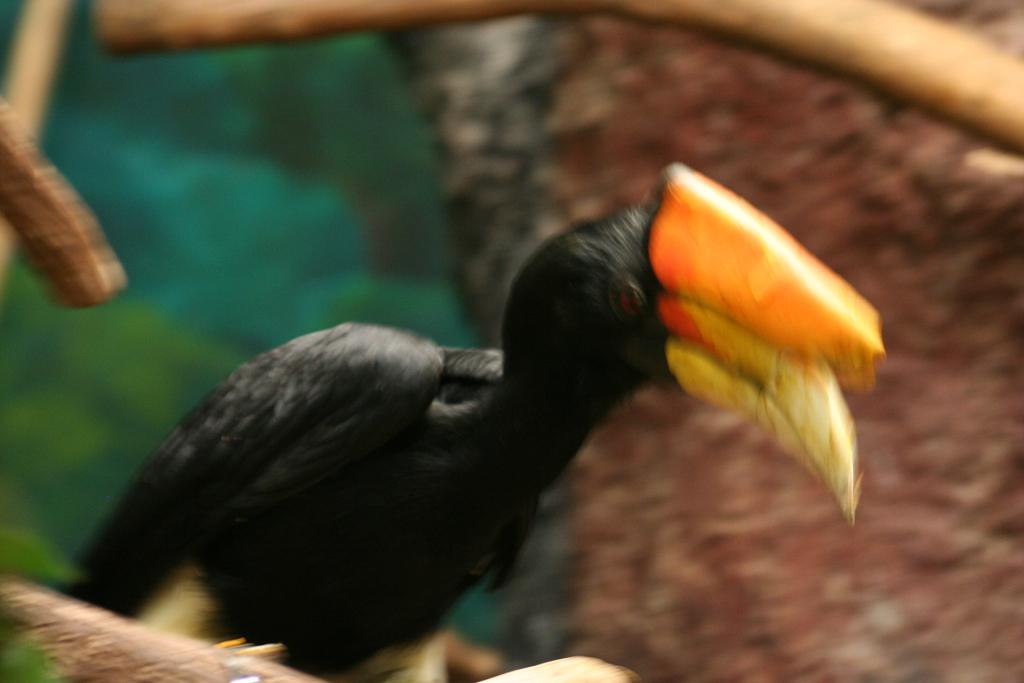What type of animal is in the image? There is a bird in the image. Can you describe the bird's coloring? The bird has yellow, orange, and black coloring. How would you describe the background of the image? The background of the image is blurry. What colors are present in the background? The background colors are brown and green. How many thumbs does the bird have in the image? Birds do not have thumbs, so this question cannot be answered based on the image. 